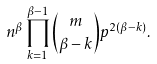<formula> <loc_0><loc_0><loc_500><loc_500>n ^ { \beta } \prod _ { k = 1 } ^ { \beta - 1 } { m \choose \beta - k } p ^ { 2 ( \beta - k ) } .</formula> 